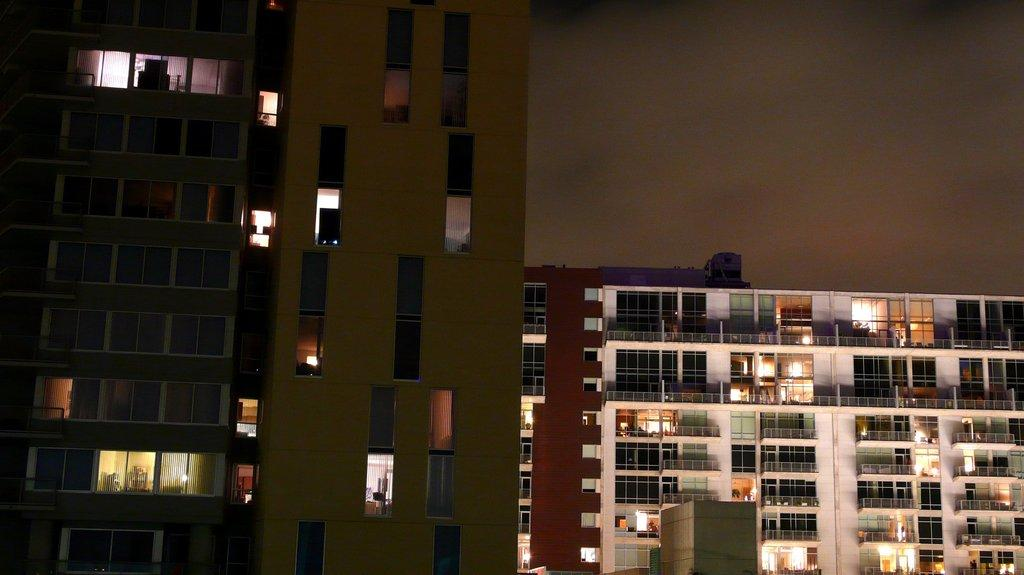What type of structures are located in the center of the image? There are buildings with windows in the center of the image. What is visible at the top of the image? The sky is visible at the top of the image. How many boys are sitting on the throne in the image? There are no boys or throne present in the image. What color are the hands of the person in the image? There is no person present in the image, so it is not possible to determine the color of their hands. 